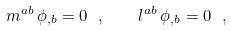Convert formula to latex. <formula><loc_0><loc_0><loc_500><loc_500>m ^ { a b } \, \phi _ { , b } = 0 \ , \quad l ^ { a b } \, \phi _ { , b } = 0 \ ,</formula> 